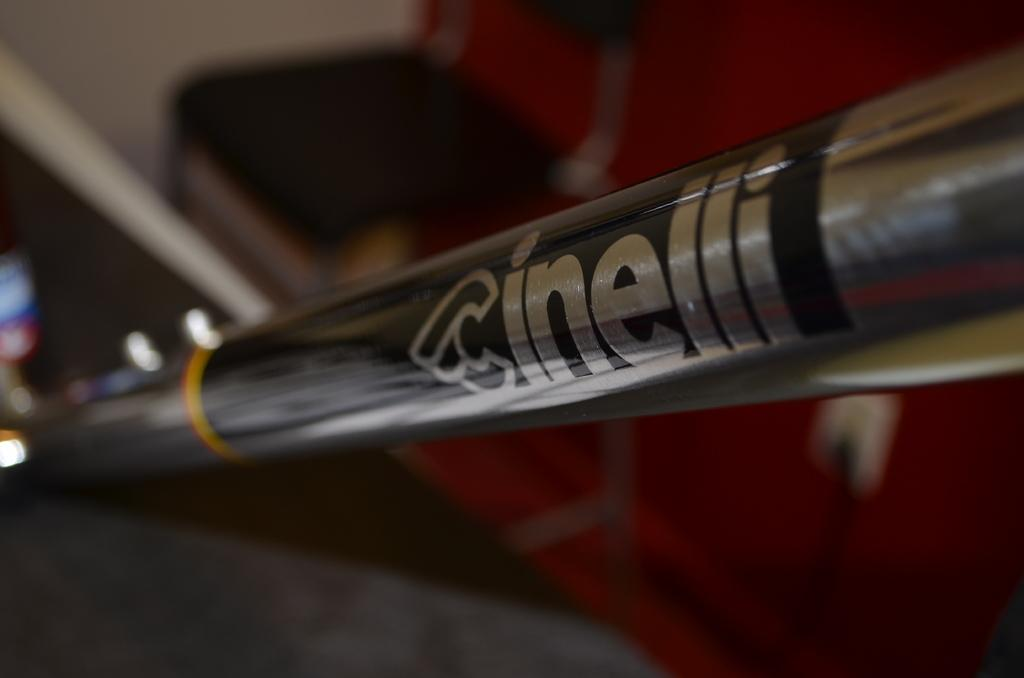What is located in the foreground of the image? There is a pipe, text, and lights in the foreground of the image. What might be the purpose of the text in the image? The text in the image could be providing information or instructions related to the pipe or lights. Can you describe the lighting conditions in the image? The presence of lights in the foreground suggests that the image may have been taken during the night or in a dimly lit area. How many girls are participating in the competition in the image? There are no girls or competition present in the image; it features a pipe, text, and lights in the foreground. 